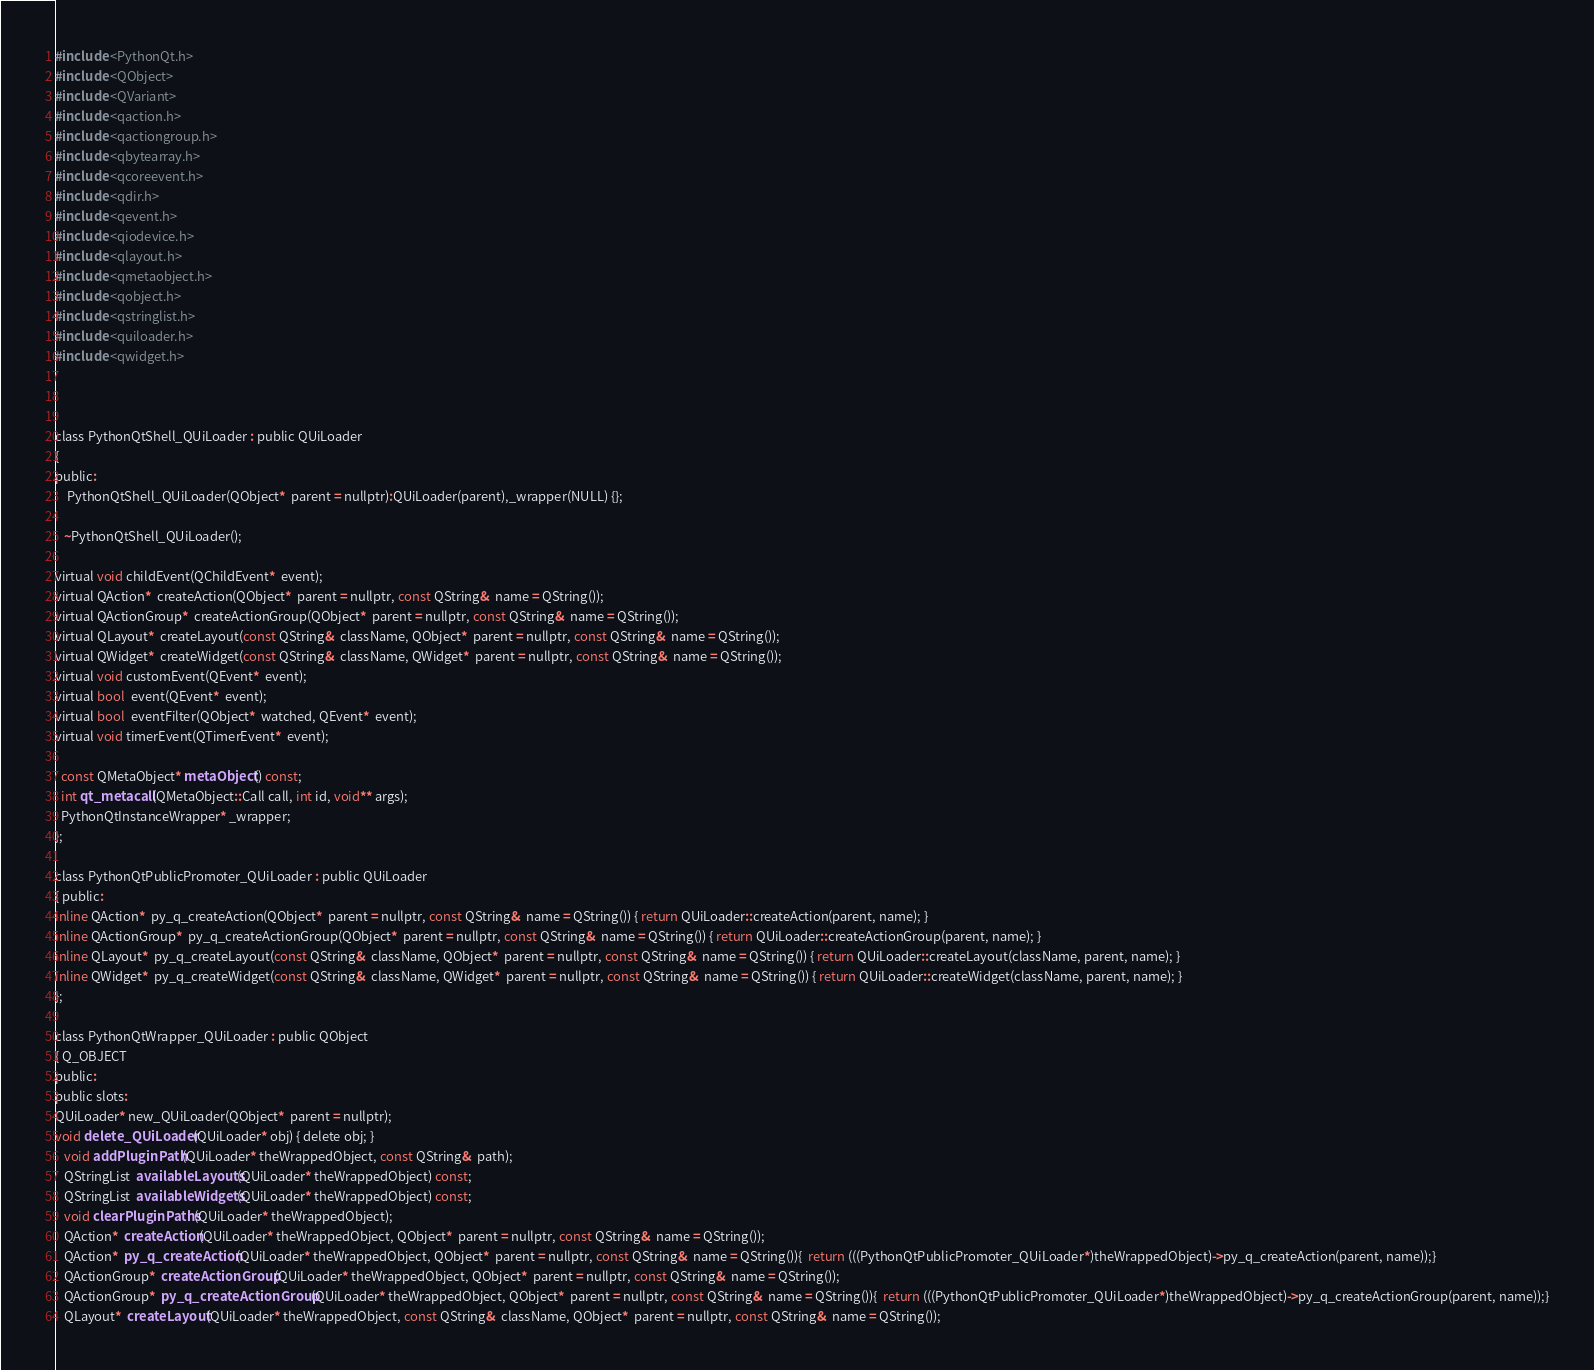Convert code to text. <code><loc_0><loc_0><loc_500><loc_500><_C_>#include <PythonQt.h>
#include <QObject>
#include <QVariant>
#include <qaction.h>
#include <qactiongroup.h>
#include <qbytearray.h>
#include <qcoreevent.h>
#include <qdir.h>
#include <qevent.h>
#include <qiodevice.h>
#include <qlayout.h>
#include <qmetaobject.h>
#include <qobject.h>
#include <qstringlist.h>
#include <quiloader.h>
#include <qwidget.h>



class PythonQtShell_QUiLoader : public QUiLoader
{
public:
    PythonQtShell_QUiLoader(QObject*  parent = nullptr):QUiLoader(parent),_wrapper(NULL) {};

   ~PythonQtShell_QUiLoader();

virtual void childEvent(QChildEvent*  event);
virtual QAction*  createAction(QObject*  parent = nullptr, const QString&  name = QString());
virtual QActionGroup*  createActionGroup(QObject*  parent = nullptr, const QString&  name = QString());
virtual QLayout*  createLayout(const QString&  className, QObject*  parent = nullptr, const QString&  name = QString());
virtual QWidget*  createWidget(const QString&  className, QWidget*  parent = nullptr, const QString&  name = QString());
virtual void customEvent(QEvent*  event);
virtual bool  event(QEvent*  event);
virtual bool  eventFilter(QObject*  watched, QEvent*  event);
virtual void timerEvent(QTimerEvent*  event);

  const QMetaObject* metaObject() const;
  int qt_metacall(QMetaObject::Call call, int id, void** args);
  PythonQtInstanceWrapper* _wrapper; 
};

class PythonQtPublicPromoter_QUiLoader : public QUiLoader
{ public:
inline QAction*  py_q_createAction(QObject*  parent = nullptr, const QString&  name = QString()) { return QUiLoader::createAction(parent, name); }
inline QActionGroup*  py_q_createActionGroup(QObject*  parent = nullptr, const QString&  name = QString()) { return QUiLoader::createActionGroup(parent, name); }
inline QLayout*  py_q_createLayout(const QString&  className, QObject*  parent = nullptr, const QString&  name = QString()) { return QUiLoader::createLayout(className, parent, name); }
inline QWidget*  py_q_createWidget(const QString&  className, QWidget*  parent = nullptr, const QString&  name = QString()) { return QUiLoader::createWidget(className, parent, name); }
};

class PythonQtWrapper_QUiLoader : public QObject
{ Q_OBJECT
public:
public slots:
QUiLoader* new_QUiLoader(QObject*  parent = nullptr);
void delete_QUiLoader(QUiLoader* obj) { delete obj; } 
   void addPluginPath(QUiLoader* theWrappedObject, const QString&  path);
   QStringList  availableLayouts(QUiLoader* theWrappedObject) const;
   QStringList  availableWidgets(QUiLoader* theWrappedObject) const;
   void clearPluginPaths(QUiLoader* theWrappedObject);
   QAction*  createAction(QUiLoader* theWrappedObject, QObject*  parent = nullptr, const QString&  name = QString());
   QAction*  py_q_createAction(QUiLoader* theWrappedObject, QObject*  parent = nullptr, const QString&  name = QString()){  return (((PythonQtPublicPromoter_QUiLoader*)theWrappedObject)->py_q_createAction(parent, name));}
   QActionGroup*  createActionGroup(QUiLoader* theWrappedObject, QObject*  parent = nullptr, const QString&  name = QString());
   QActionGroup*  py_q_createActionGroup(QUiLoader* theWrappedObject, QObject*  parent = nullptr, const QString&  name = QString()){  return (((PythonQtPublicPromoter_QUiLoader*)theWrappedObject)->py_q_createActionGroup(parent, name));}
   QLayout*  createLayout(QUiLoader* theWrappedObject, const QString&  className, QObject*  parent = nullptr, const QString&  name = QString());</code> 